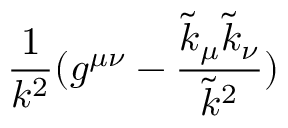Convert formula to latex. <formula><loc_0><loc_0><loc_500><loc_500>\frac { 1 } { k ^ { 2 } } ( g ^ { \mu \nu } - \frac { \tilde { k } _ { \mu } \tilde { k } _ { \nu } } { \tilde { k } ^ { 2 } } )</formula> 